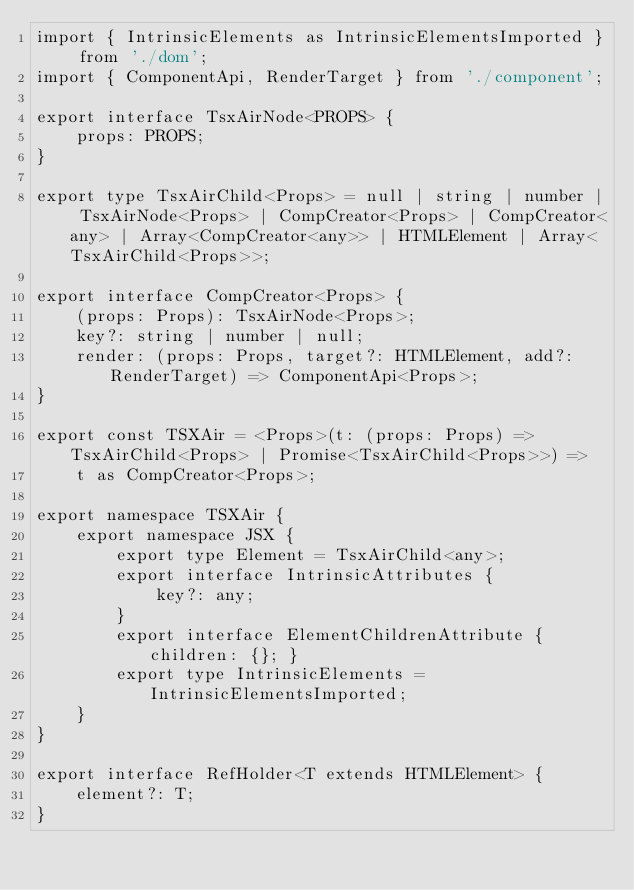Convert code to text. <code><loc_0><loc_0><loc_500><loc_500><_TypeScript_>import { IntrinsicElements as IntrinsicElementsImported } from './dom';
import { ComponentApi, RenderTarget } from './component';

export interface TsxAirNode<PROPS> {
    props: PROPS;
}

export type TsxAirChild<Props> = null | string | number | TsxAirNode<Props> | CompCreator<Props> | CompCreator<any> | Array<CompCreator<any>> | HTMLElement | Array<TsxAirChild<Props>>;

export interface CompCreator<Props> {
    (props: Props): TsxAirNode<Props>;
    key?: string | number | null;
    render: (props: Props, target?: HTMLElement, add?: RenderTarget) => ComponentApi<Props>;
}

export const TSXAir = <Props>(t: (props: Props) => TsxAirChild<Props> | Promise<TsxAirChild<Props>>) =>
    t as CompCreator<Props>;

export namespace TSXAir {
    export namespace JSX {
        export type Element = TsxAirChild<any>;
        export interface IntrinsicAttributes {
            key?: any;
        }
        export interface ElementChildrenAttribute { children: {}; }
        export type IntrinsicElements = IntrinsicElementsImported;
    }
}

export interface RefHolder<T extends HTMLElement> {
    element?: T;
}</code> 